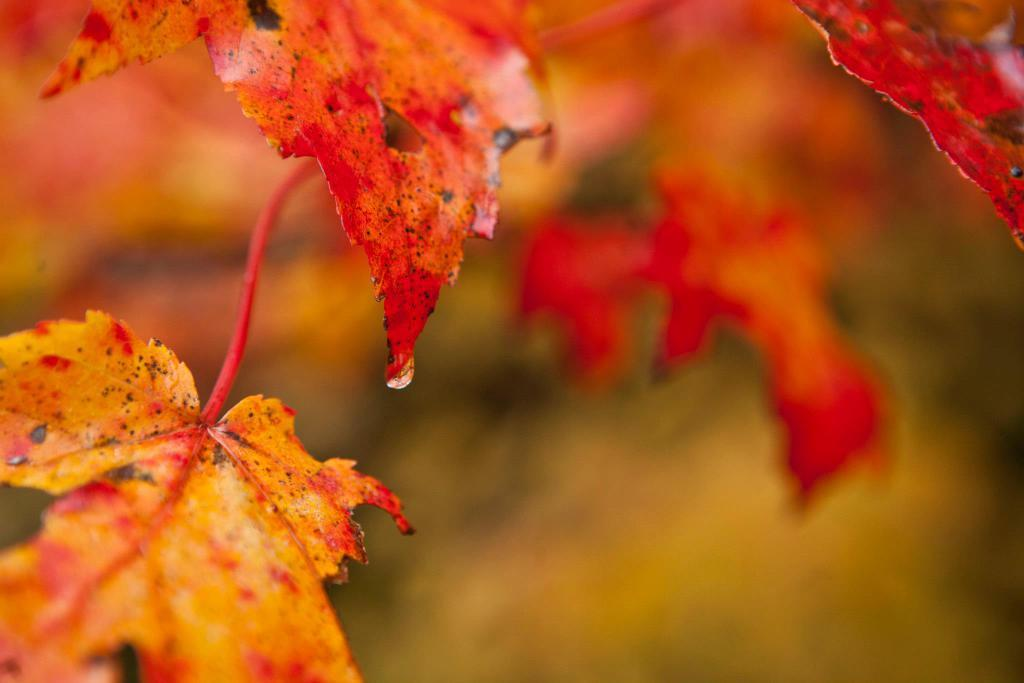What type of vegetation can be seen in the image? There are leaves in the image. Can you describe the background of the image? The background of the image is blurry. Where is the sister standing in the image? There is no sister present in the image. What type of bird can be seen perched on the dock in the image? There is no dock or bird present in the image. 